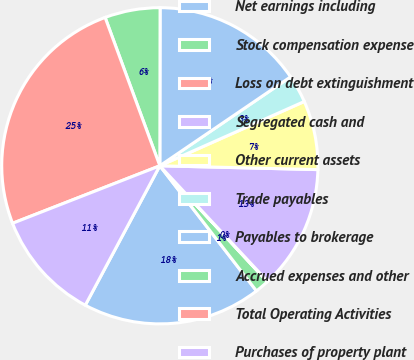<chart> <loc_0><loc_0><loc_500><loc_500><pie_chart><fcel>Net earnings including<fcel>Stock compensation expense<fcel>Loss on debt extinguishment<fcel>Segregated cash and<fcel>Other current assets<fcel>Trade payables<fcel>Payables to brokerage<fcel>Accrued expenses and other<fcel>Total Operating Activities<fcel>Purchases of property plant<nl><fcel>18.28%<fcel>1.44%<fcel>0.04%<fcel>12.67%<fcel>7.05%<fcel>2.84%<fcel>15.47%<fcel>5.65%<fcel>25.3%<fcel>11.26%<nl></chart> 